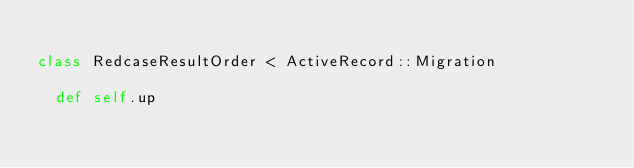<code> <loc_0><loc_0><loc_500><loc_500><_Ruby_>
class RedcaseResultOrder < ActiveRecord::Migration

  def self.up</code> 